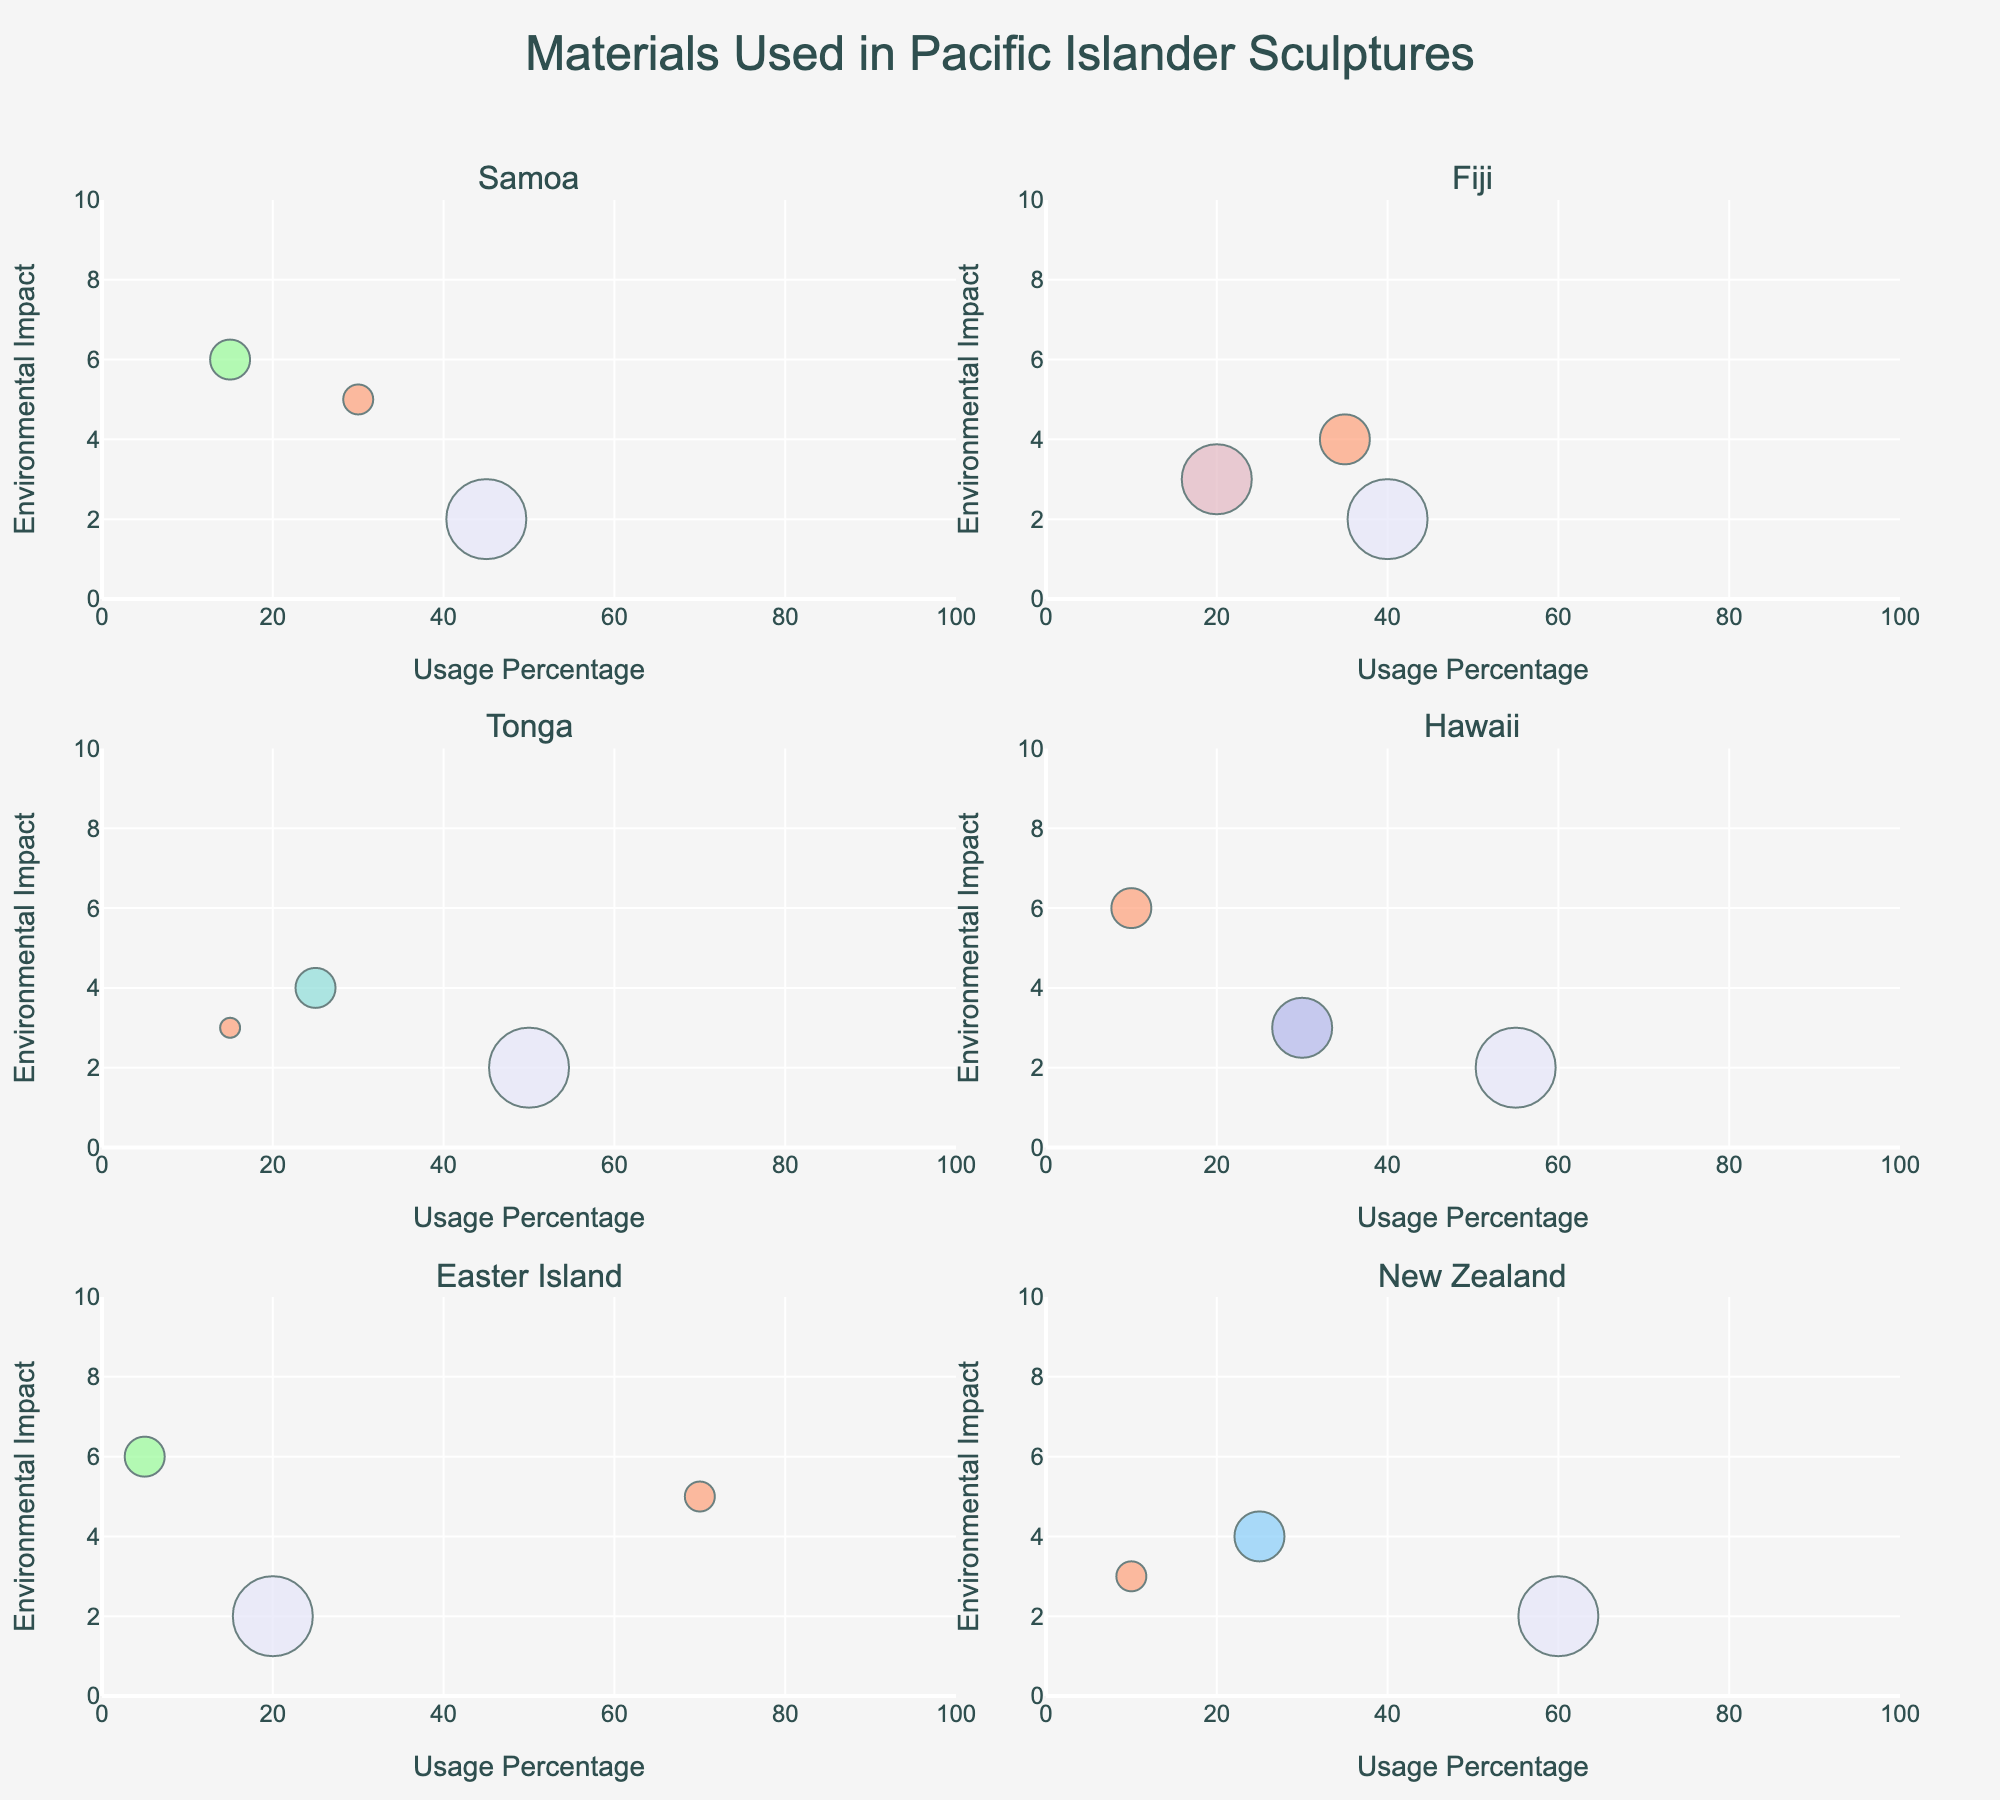How many different materials are used in sculpting in Fiji? We count the number of unique data points in the subplot for Fiji. Each bubble represents a different material.
Answer: 3 Which island uses "Coral" the least in terms of usage percentage? We compare the size (usage percentage) of the "Coral" bubbles across all subplots. Easter Island’s "Coral" bubble is the smallest.
Answer: Easter Island On which island is wood used the most per usage percentage? We look for the largest "Wood" bubble in terms of the usage percentage axis. New Zealand’s "Wood" bubble is the largest.
Answer: New Zealand Which material on Samoa has the highest environmental impact? We check the highest y-axis value in Samoa’s subplot and identify the corresponding material. "Coral" has the highest y-axis value for environmental impact.
Answer: Coral What is the common characteristic of all materials used in Hawaii in terms of renewable score? All bubbles in Hawaii’s subplot have a renewable score reflected in their size as 5* the score. "Wood" scores 8, "Lava Rock" scores 6, and "Coral" scores 4, which shows all materials are renewables ranging from 4-8.
Answer: Renewable score ranges from 4-8 Which islands have materials with an environmental impact score greater than 5? We identify bubbles in the plots with a y-axis value greater than 5 for each island. Both Samoa and Hawaii have "Coral" with an environmental impact score of 6.
Answer: Samoa, Hawaii How many materials have a renewable score of 8 across all islands? We count the number of bubbles where renewable scores (size of the bubbles / 5) are 8. There are materials on Samoa, Fiji, Tonga, Hawaii, Easter Island, and New Zealand that have this score. The total count is 6 (one per island mentioned).
Answer: 6 Between Fiji and Tonga, which island relies more on stone-based materials based on usage percentage? We sum the usage percentages of stone-based materials (Soapstone and Limestone) for both islands. Fiji: Soapstone 35%, Tonga: Limestone 25%. Fiji relies more at 35%.
Answer: Fiji Which material on Easter Island has the highest usage percentage? We find the largest bubble in Easter Island’s subplot by usage percentage axis. "Basalt" has the highest at 70%.
Answer: Basalt Is there any island where a material has a renewable score equal to or below 2? We look for any bubble in all the subplots with a size correlating to renewable score 2. Tonga's "Whalebone" has a renewable score of 2.
Answer: Yes, Tonga 